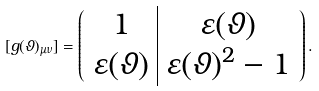<formula> <loc_0><loc_0><loc_500><loc_500>[ g ( \vartheta ) _ { \mu \nu } ] = \left ( \begin{array} { c | c } 1 & \varepsilon ( \vartheta ) \\ \varepsilon ( \vartheta ) & \varepsilon ( \vartheta ) ^ { 2 } - 1 \end{array} \right ) .</formula> 